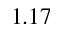<formula> <loc_0><loc_0><loc_500><loc_500>1 . 1 7</formula> 